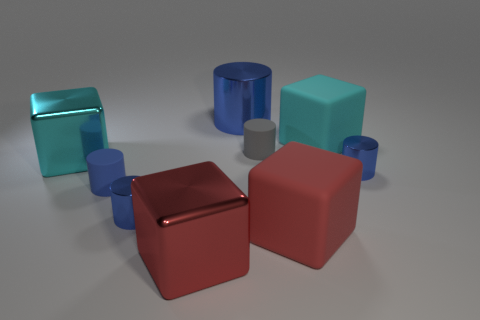What number of other things are there of the same size as the red matte cube?
Your answer should be compact. 4. The big thing that is right of the gray matte object and in front of the tiny gray object is made of what material?
Your response must be concise. Rubber. What material is the other large red object that is the same shape as the red rubber thing?
Offer a terse response. Metal. How many blue metallic objects are in front of the cube that is left of the tiny rubber cylinder that is in front of the cyan metal thing?
Provide a succinct answer. 2. Is there anything else that has the same color as the big cylinder?
Offer a terse response. Yes. How many objects are both in front of the big blue object and to the left of the big cyan rubber cube?
Keep it short and to the point. 6. There is a blue object right of the large metallic cylinder; does it have the same size as the cyan cube that is to the right of the big cylinder?
Your response must be concise. No. What number of objects are large cyan metallic blocks in front of the gray object or tiny gray matte cylinders?
Give a very brief answer. 2. What is the material of the large cylinder that is to the right of the blue rubber thing?
Offer a terse response. Metal. What is the material of the gray thing?
Offer a terse response. Rubber. 